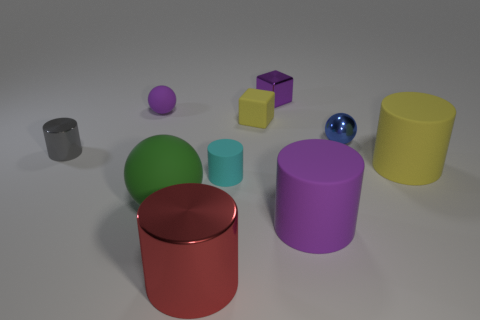What number of other objects are the same material as the large yellow cylinder?
Your answer should be compact. 5. There is a yellow rubber thing that is the same shape as the tiny cyan matte object; what is its size?
Offer a very short reply. Large. Does the small rubber sphere have the same color as the tiny metallic cube?
Provide a short and direct response. Yes. What color is the object that is both on the left side of the green object and to the right of the tiny gray cylinder?
Offer a very short reply. Purple. What number of things are metallic objects behind the large yellow rubber thing or small cyan rubber cylinders?
Offer a very short reply. 4. There is another small shiny thing that is the same shape as the cyan object; what is its color?
Offer a very short reply. Gray. Does the green thing have the same shape as the yellow object in front of the small yellow rubber block?
Offer a terse response. No. What number of things are objects that are on the right side of the large ball or small matte things behind the small gray metal cylinder?
Your answer should be compact. 8. Are there fewer small cyan cylinders behind the metallic ball than big gray matte balls?
Give a very brief answer. No. Is the tiny yellow block made of the same material as the cylinder that is to the left of the green ball?
Your answer should be very brief. No. 